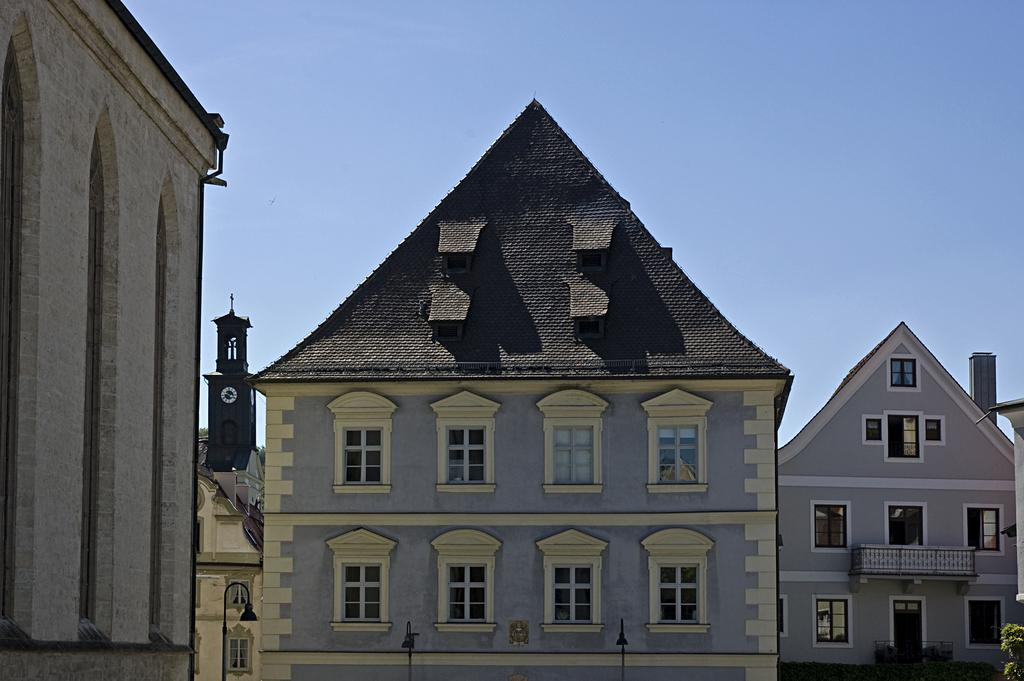What type of structures can be seen in the image? There are buildings in the image. What type of lighting is present in the image? There is a street lamp in the image. What time-related object is visible in the image? There is a clock in the image. What is visible at the top of the image? The sky is visible at the top of the image. Where is the drain located in the image? There is no drain present in the image. How many feet are visible in the image? There are no feet visible in the image. 